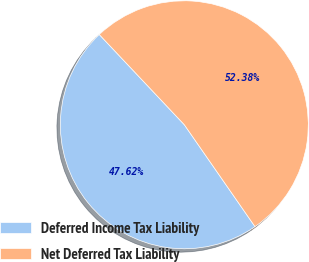Convert chart to OTSL. <chart><loc_0><loc_0><loc_500><loc_500><pie_chart><fcel>Deferred Income Tax Liability<fcel>Net Deferred Tax Liability<nl><fcel>47.62%<fcel>52.38%<nl></chart> 